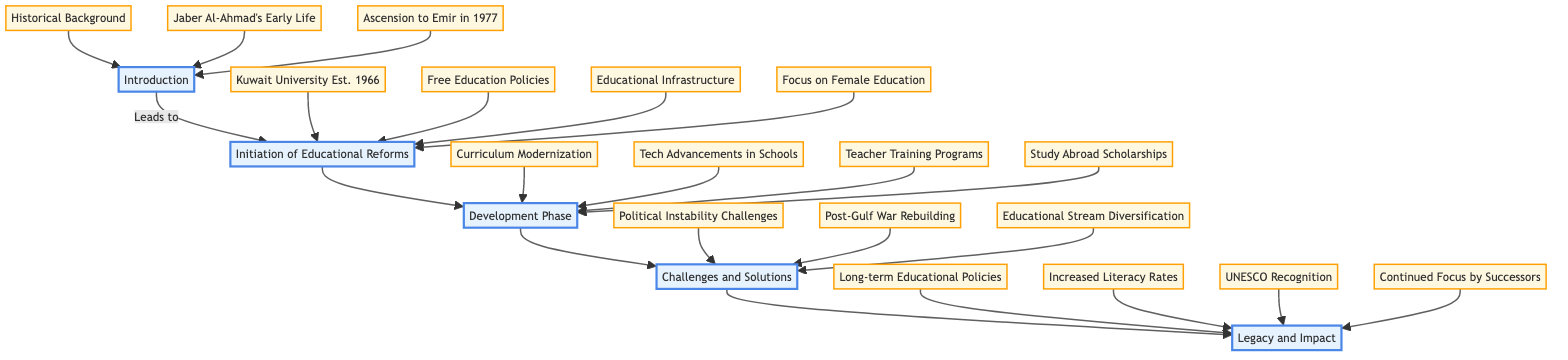What is the title of the diagram? The title is explicitly stated at the top of the diagram, which is "The Influence of Jaber Al-Ahmad Al-Jaber Al-Sabah on Kuwait's Education System."
Answer: The Influence of Jaber Al-Ahmad Al-Jaber Al-Sabah on Kuwait's Education System How many stages are there in the clinical pathway? By counting the stages listed in the diagram, we find there are five distinct stages: Introduction, Initiation of Educational Reforms, Development Phase, Challenges and Solutions, and Legacy and Impact.
Answer: 5 What is the first key element in the Initiation of Educational Reforms stage? The first key element listed under the Initiation of Educational Reforms is "Establishment of Kuwait University (1966)."
Answer: Establishment of Kuwait University (1966) What leads to the Development Phase? The Development Phase is directly connected to the previous stage, which is "Initiation of Educational Reforms," indicating it is the next logical step following that stage.
Answer: Initiation of Educational Reforms What are two key elements of the Legacy and Impact stage? The Legacy and Impact stage lists four key elements, out of which two can be "Long-term Educational Policies" and "Increased Literacy Rates," either of which is valid.
Answer: Long-term Educational Policies and Increased Literacy Rates What challenges was the education system facing according to the Challenges and Solutions stage? This stage specifically mentions "Challenges Due to Political Instability" as one of the significant challenges faced by the education system, along with other issues.
Answer: Challenges Due to Political Instability Which stage follows the Development Phase? The Development Phase is followed by the "Challenges and Solutions" stage, showing a progression where development leads to addressing challenges.
Answer: Challenges and Solutions How did Jaber Al-Ahmad Al-Jaber Al-Sabah influence female education? The Influence on female education is explicitly mentioned as a key element under the Initiation of Educational Reforms stage, indicating a focus in this area.
Answer: Focus on Female Education What was a key initiative supporting teachers during the Development Phase? A specific initiative mentioned in the Development Phase is "Training Programs for Teachers," which represents investment in enhancing teaching capabilities.
Answer: Training Programs for Teachers 